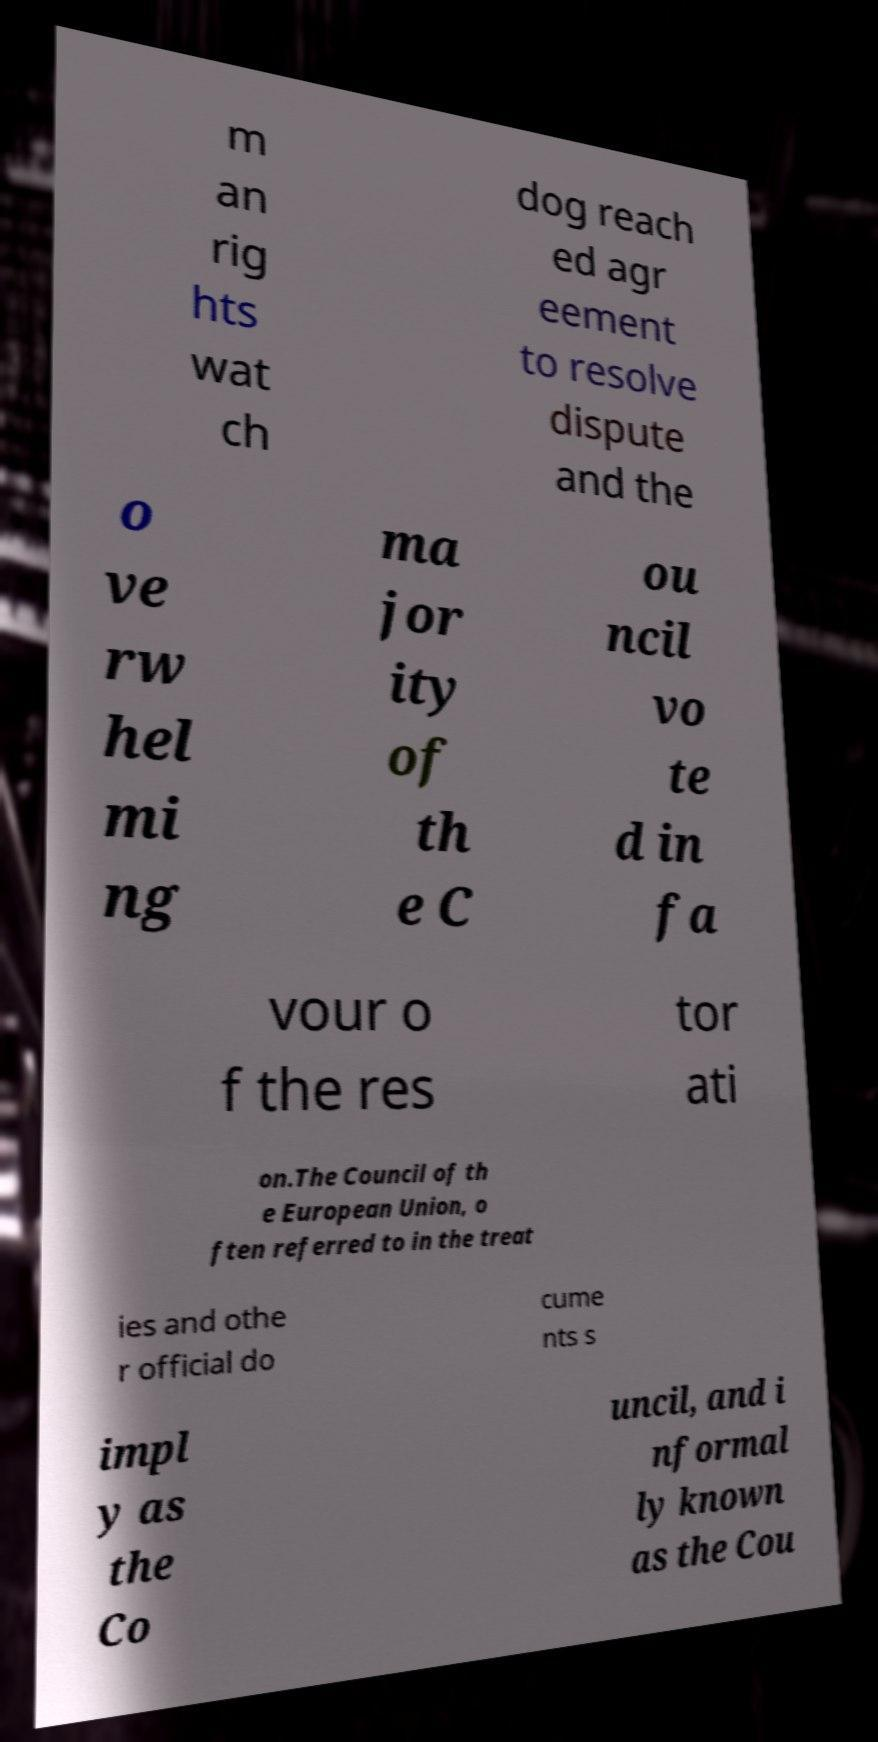What messages or text are displayed in this image? I need them in a readable, typed format. m an rig hts wat ch dog reach ed agr eement to resolve dispute and the o ve rw hel mi ng ma jor ity of th e C ou ncil vo te d in fa vour o f the res tor ati on.The Council of th e European Union, o ften referred to in the treat ies and othe r official do cume nts s impl y as the Co uncil, and i nformal ly known as the Cou 